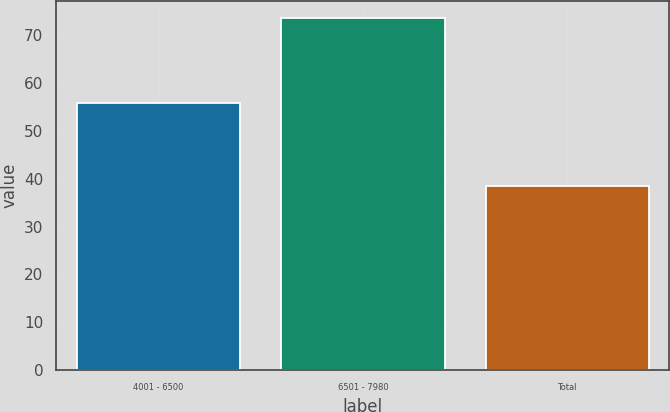<chart> <loc_0><loc_0><loc_500><loc_500><bar_chart><fcel>4001 - 6500<fcel>6501 - 7980<fcel>Total<nl><fcel>55.72<fcel>73.53<fcel>38.47<nl></chart> 